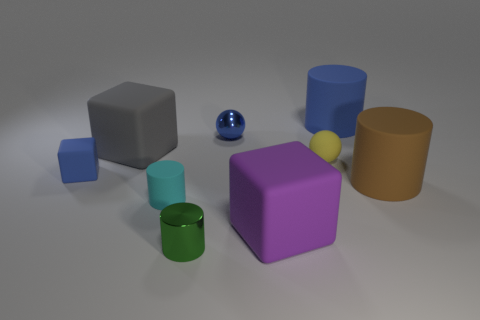Subtract all cyan matte cylinders. How many cylinders are left? 3 Subtract all balls. How many objects are left? 7 Subtract all gray blocks. How many blocks are left? 2 Subtract 1 spheres. How many spheres are left? 1 Add 5 brown cylinders. How many brown cylinders are left? 6 Add 3 matte things. How many matte things exist? 10 Add 1 purple cubes. How many objects exist? 10 Subtract 0 yellow cubes. How many objects are left? 9 Subtract all purple balls. Subtract all green cylinders. How many balls are left? 2 Subtract all yellow cylinders. How many cyan spheres are left? 0 